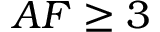Convert formula to latex. <formula><loc_0><loc_0><loc_500><loc_500>A F \geq 3</formula> 